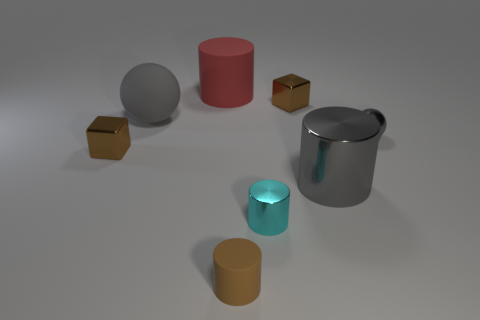Subtract all tiny brown cylinders. How many cylinders are left? 3 Subtract all gray cylinders. How many cylinders are left? 3 Subtract all blue cylinders. Subtract all cyan blocks. How many cylinders are left? 4 Add 2 big brown objects. How many objects exist? 10 Subtract all blocks. How many objects are left? 6 Subtract all tiny blue things. Subtract all gray metal things. How many objects are left? 6 Add 1 gray rubber objects. How many gray rubber objects are left? 2 Add 5 small yellow blocks. How many small yellow blocks exist? 5 Subtract 0 purple spheres. How many objects are left? 8 